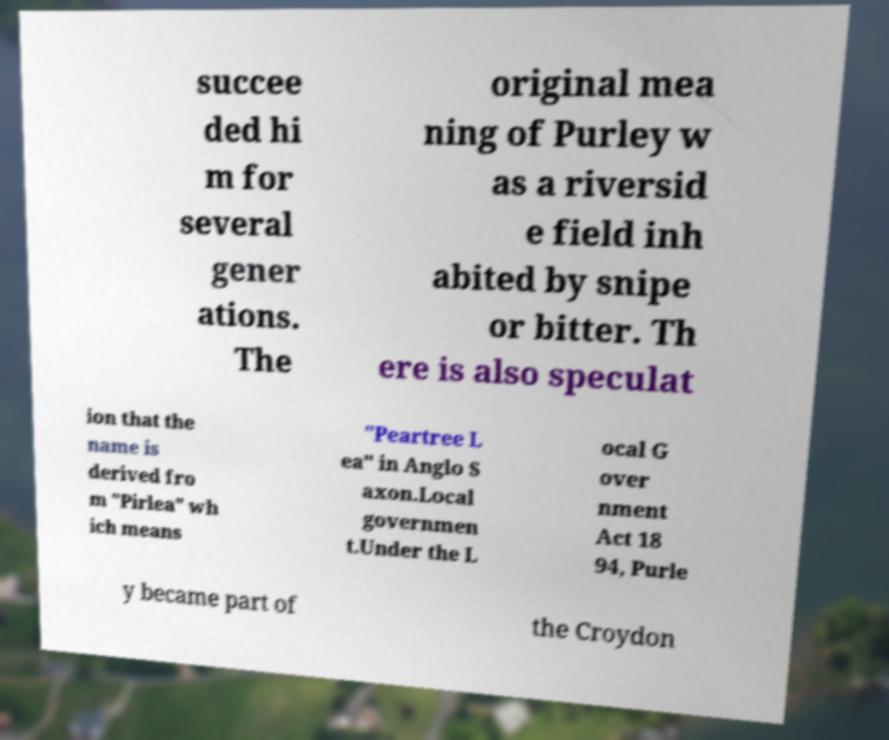Please identify and transcribe the text found in this image. succee ded hi m for several gener ations. The original mea ning of Purley w as a riversid e field inh abited by snipe or bitter. Th ere is also speculat ion that the name is derived fro m "Pirlea" wh ich means "Peartree L ea" in Anglo S axon.Local governmen t.Under the L ocal G over nment Act 18 94, Purle y became part of the Croydon 